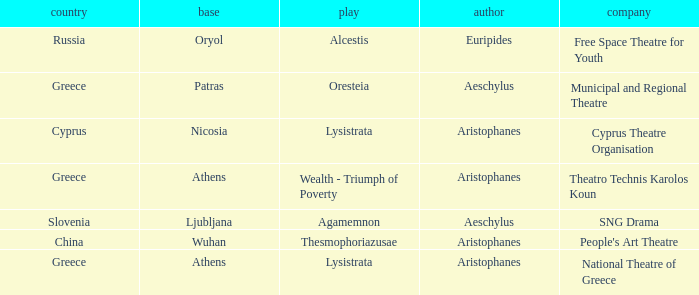What is the base when the play is thesmophoriazusae? Wuhan. 